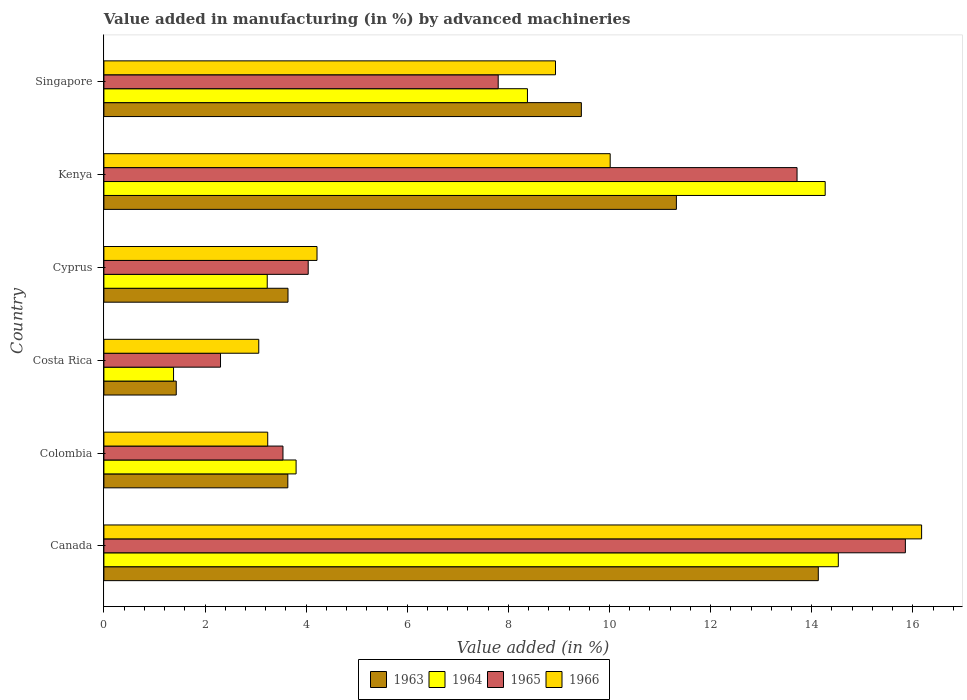How many different coloured bars are there?
Provide a short and direct response. 4. How many groups of bars are there?
Offer a very short reply. 6. What is the label of the 5th group of bars from the top?
Make the answer very short. Colombia. What is the percentage of value added in manufacturing by advanced machineries in 1963 in Kenya?
Offer a terse response. 11.32. Across all countries, what is the maximum percentage of value added in manufacturing by advanced machineries in 1965?
Keep it short and to the point. 15.85. Across all countries, what is the minimum percentage of value added in manufacturing by advanced machineries in 1963?
Keep it short and to the point. 1.43. In which country was the percentage of value added in manufacturing by advanced machineries in 1966 maximum?
Give a very brief answer. Canada. What is the total percentage of value added in manufacturing by advanced machineries in 1966 in the graph?
Your answer should be compact. 45.64. What is the difference between the percentage of value added in manufacturing by advanced machineries in 1963 in Kenya and that in Singapore?
Your answer should be very brief. 1.88. What is the difference between the percentage of value added in manufacturing by advanced machineries in 1966 in Colombia and the percentage of value added in manufacturing by advanced machineries in 1963 in Canada?
Offer a very short reply. -10.89. What is the average percentage of value added in manufacturing by advanced machineries in 1963 per country?
Your answer should be very brief. 7.27. What is the difference between the percentage of value added in manufacturing by advanced machineries in 1965 and percentage of value added in manufacturing by advanced machineries in 1964 in Colombia?
Keep it short and to the point. -0.26. In how many countries, is the percentage of value added in manufacturing by advanced machineries in 1963 greater than 2.4 %?
Provide a succinct answer. 5. What is the ratio of the percentage of value added in manufacturing by advanced machineries in 1965 in Kenya to that in Singapore?
Give a very brief answer. 1.76. Is the percentage of value added in manufacturing by advanced machineries in 1965 in Cyprus less than that in Kenya?
Make the answer very short. Yes. Is the difference between the percentage of value added in manufacturing by advanced machineries in 1965 in Canada and Colombia greater than the difference between the percentage of value added in manufacturing by advanced machineries in 1964 in Canada and Colombia?
Your answer should be very brief. Yes. What is the difference between the highest and the second highest percentage of value added in manufacturing by advanced machineries in 1964?
Ensure brevity in your answer.  0.26. What is the difference between the highest and the lowest percentage of value added in manufacturing by advanced machineries in 1963?
Your answer should be very brief. 12.7. What does the 2nd bar from the top in Costa Rica represents?
Your response must be concise. 1965. What does the 3rd bar from the bottom in Kenya represents?
Keep it short and to the point. 1965. Is it the case that in every country, the sum of the percentage of value added in manufacturing by advanced machineries in 1964 and percentage of value added in manufacturing by advanced machineries in 1966 is greater than the percentage of value added in manufacturing by advanced machineries in 1963?
Your answer should be compact. Yes. Are all the bars in the graph horizontal?
Offer a terse response. Yes. Does the graph contain any zero values?
Your answer should be very brief. No. Does the graph contain grids?
Make the answer very short. No. How many legend labels are there?
Your answer should be very brief. 4. What is the title of the graph?
Provide a short and direct response. Value added in manufacturing (in %) by advanced machineries. Does "1988" appear as one of the legend labels in the graph?
Provide a succinct answer. No. What is the label or title of the X-axis?
Your response must be concise. Value added (in %). What is the label or title of the Y-axis?
Offer a very short reply. Country. What is the Value added (in %) in 1963 in Canada?
Your answer should be compact. 14.13. What is the Value added (in %) in 1964 in Canada?
Offer a very short reply. 14.53. What is the Value added (in %) in 1965 in Canada?
Ensure brevity in your answer.  15.85. What is the Value added (in %) of 1966 in Canada?
Make the answer very short. 16.17. What is the Value added (in %) of 1963 in Colombia?
Provide a short and direct response. 3.64. What is the Value added (in %) in 1964 in Colombia?
Provide a succinct answer. 3.8. What is the Value added (in %) of 1965 in Colombia?
Provide a short and direct response. 3.54. What is the Value added (in %) of 1966 in Colombia?
Provide a short and direct response. 3.24. What is the Value added (in %) in 1963 in Costa Rica?
Keep it short and to the point. 1.43. What is the Value added (in %) in 1964 in Costa Rica?
Your answer should be compact. 1.38. What is the Value added (in %) in 1965 in Costa Rica?
Provide a short and direct response. 2.31. What is the Value added (in %) of 1966 in Costa Rica?
Offer a terse response. 3.06. What is the Value added (in %) of 1963 in Cyprus?
Provide a succinct answer. 3.64. What is the Value added (in %) in 1964 in Cyprus?
Your answer should be very brief. 3.23. What is the Value added (in %) in 1965 in Cyprus?
Make the answer very short. 4.04. What is the Value added (in %) in 1966 in Cyprus?
Make the answer very short. 4.22. What is the Value added (in %) of 1963 in Kenya?
Give a very brief answer. 11.32. What is the Value added (in %) in 1964 in Kenya?
Offer a very short reply. 14.27. What is the Value added (in %) in 1965 in Kenya?
Your answer should be compact. 13.71. What is the Value added (in %) in 1966 in Kenya?
Offer a very short reply. 10.01. What is the Value added (in %) in 1963 in Singapore?
Offer a terse response. 9.44. What is the Value added (in %) in 1964 in Singapore?
Give a very brief answer. 8.38. What is the Value added (in %) of 1965 in Singapore?
Offer a terse response. 7.8. What is the Value added (in %) of 1966 in Singapore?
Offer a very short reply. 8.93. Across all countries, what is the maximum Value added (in %) of 1963?
Your answer should be compact. 14.13. Across all countries, what is the maximum Value added (in %) in 1964?
Give a very brief answer. 14.53. Across all countries, what is the maximum Value added (in %) of 1965?
Provide a short and direct response. 15.85. Across all countries, what is the maximum Value added (in %) in 1966?
Ensure brevity in your answer.  16.17. Across all countries, what is the minimum Value added (in %) in 1963?
Give a very brief answer. 1.43. Across all countries, what is the minimum Value added (in %) in 1964?
Offer a terse response. 1.38. Across all countries, what is the minimum Value added (in %) in 1965?
Your answer should be very brief. 2.31. Across all countries, what is the minimum Value added (in %) of 1966?
Offer a very short reply. 3.06. What is the total Value added (in %) in 1963 in the graph?
Make the answer very short. 43.61. What is the total Value added (in %) in 1964 in the graph?
Make the answer very short. 45.58. What is the total Value added (in %) of 1965 in the graph?
Offer a very short reply. 47.25. What is the total Value added (in %) of 1966 in the graph?
Provide a short and direct response. 45.64. What is the difference between the Value added (in %) of 1963 in Canada and that in Colombia?
Your answer should be very brief. 10.49. What is the difference between the Value added (in %) in 1964 in Canada and that in Colombia?
Provide a short and direct response. 10.72. What is the difference between the Value added (in %) of 1965 in Canada and that in Colombia?
Offer a very short reply. 12.31. What is the difference between the Value added (in %) of 1966 in Canada and that in Colombia?
Provide a short and direct response. 12.93. What is the difference between the Value added (in %) in 1963 in Canada and that in Costa Rica?
Offer a terse response. 12.7. What is the difference between the Value added (in %) in 1964 in Canada and that in Costa Rica?
Your response must be concise. 13.15. What is the difference between the Value added (in %) in 1965 in Canada and that in Costa Rica?
Ensure brevity in your answer.  13.55. What is the difference between the Value added (in %) of 1966 in Canada and that in Costa Rica?
Provide a short and direct response. 13.11. What is the difference between the Value added (in %) in 1963 in Canada and that in Cyprus?
Provide a short and direct response. 10.49. What is the difference between the Value added (in %) in 1964 in Canada and that in Cyprus?
Provide a succinct answer. 11.3. What is the difference between the Value added (in %) in 1965 in Canada and that in Cyprus?
Provide a short and direct response. 11.81. What is the difference between the Value added (in %) of 1966 in Canada and that in Cyprus?
Provide a short and direct response. 11.96. What is the difference between the Value added (in %) in 1963 in Canada and that in Kenya?
Offer a terse response. 2.81. What is the difference between the Value added (in %) of 1964 in Canada and that in Kenya?
Offer a very short reply. 0.26. What is the difference between the Value added (in %) of 1965 in Canada and that in Kenya?
Provide a succinct answer. 2.14. What is the difference between the Value added (in %) in 1966 in Canada and that in Kenya?
Offer a very short reply. 6.16. What is the difference between the Value added (in %) of 1963 in Canada and that in Singapore?
Offer a terse response. 4.69. What is the difference between the Value added (in %) of 1964 in Canada and that in Singapore?
Ensure brevity in your answer.  6.15. What is the difference between the Value added (in %) in 1965 in Canada and that in Singapore?
Ensure brevity in your answer.  8.05. What is the difference between the Value added (in %) in 1966 in Canada and that in Singapore?
Offer a terse response. 7.24. What is the difference between the Value added (in %) in 1963 in Colombia and that in Costa Rica?
Make the answer very short. 2.21. What is the difference between the Value added (in %) of 1964 in Colombia and that in Costa Rica?
Provide a succinct answer. 2.42. What is the difference between the Value added (in %) in 1965 in Colombia and that in Costa Rica?
Provide a succinct answer. 1.24. What is the difference between the Value added (in %) of 1966 in Colombia and that in Costa Rica?
Keep it short and to the point. 0.18. What is the difference between the Value added (in %) in 1963 in Colombia and that in Cyprus?
Ensure brevity in your answer.  -0. What is the difference between the Value added (in %) in 1964 in Colombia and that in Cyprus?
Ensure brevity in your answer.  0.57. What is the difference between the Value added (in %) in 1965 in Colombia and that in Cyprus?
Keep it short and to the point. -0.5. What is the difference between the Value added (in %) of 1966 in Colombia and that in Cyprus?
Provide a short and direct response. -0.97. What is the difference between the Value added (in %) of 1963 in Colombia and that in Kenya?
Provide a succinct answer. -7.69. What is the difference between the Value added (in %) in 1964 in Colombia and that in Kenya?
Provide a short and direct response. -10.47. What is the difference between the Value added (in %) of 1965 in Colombia and that in Kenya?
Offer a very short reply. -10.17. What is the difference between the Value added (in %) in 1966 in Colombia and that in Kenya?
Ensure brevity in your answer.  -6.77. What is the difference between the Value added (in %) of 1963 in Colombia and that in Singapore?
Provide a succinct answer. -5.81. What is the difference between the Value added (in %) of 1964 in Colombia and that in Singapore?
Offer a terse response. -4.58. What is the difference between the Value added (in %) in 1965 in Colombia and that in Singapore?
Your response must be concise. -4.26. What is the difference between the Value added (in %) of 1966 in Colombia and that in Singapore?
Offer a very short reply. -5.69. What is the difference between the Value added (in %) in 1963 in Costa Rica and that in Cyprus?
Make the answer very short. -2.21. What is the difference between the Value added (in %) of 1964 in Costa Rica and that in Cyprus?
Provide a succinct answer. -1.85. What is the difference between the Value added (in %) of 1965 in Costa Rica and that in Cyprus?
Provide a short and direct response. -1.73. What is the difference between the Value added (in %) in 1966 in Costa Rica and that in Cyprus?
Your answer should be very brief. -1.15. What is the difference between the Value added (in %) of 1963 in Costa Rica and that in Kenya?
Offer a very short reply. -9.89. What is the difference between the Value added (in %) in 1964 in Costa Rica and that in Kenya?
Ensure brevity in your answer.  -12.89. What is the difference between the Value added (in %) in 1965 in Costa Rica and that in Kenya?
Your answer should be very brief. -11.4. What is the difference between the Value added (in %) in 1966 in Costa Rica and that in Kenya?
Make the answer very short. -6.95. What is the difference between the Value added (in %) of 1963 in Costa Rica and that in Singapore?
Your response must be concise. -8.01. What is the difference between the Value added (in %) of 1964 in Costa Rica and that in Singapore?
Give a very brief answer. -7. What is the difference between the Value added (in %) in 1965 in Costa Rica and that in Singapore?
Ensure brevity in your answer.  -5.49. What is the difference between the Value added (in %) of 1966 in Costa Rica and that in Singapore?
Make the answer very short. -5.87. What is the difference between the Value added (in %) of 1963 in Cyprus and that in Kenya?
Your response must be concise. -7.68. What is the difference between the Value added (in %) in 1964 in Cyprus and that in Kenya?
Make the answer very short. -11.04. What is the difference between the Value added (in %) of 1965 in Cyprus and that in Kenya?
Your response must be concise. -9.67. What is the difference between the Value added (in %) in 1966 in Cyprus and that in Kenya?
Make the answer very short. -5.8. What is the difference between the Value added (in %) in 1963 in Cyprus and that in Singapore?
Offer a terse response. -5.8. What is the difference between the Value added (in %) of 1964 in Cyprus and that in Singapore?
Make the answer very short. -5.15. What is the difference between the Value added (in %) of 1965 in Cyprus and that in Singapore?
Offer a terse response. -3.76. What is the difference between the Value added (in %) in 1966 in Cyprus and that in Singapore?
Ensure brevity in your answer.  -4.72. What is the difference between the Value added (in %) of 1963 in Kenya and that in Singapore?
Your response must be concise. 1.88. What is the difference between the Value added (in %) in 1964 in Kenya and that in Singapore?
Your answer should be very brief. 5.89. What is the difference between the Value added (in %) in 1965 in Kenya and that in Singapore?
Offer a very short reply. 5.91. What is the difference between the Value added (in %) in 1966 in Kenya and that in Singapore?
Your answer should be compact. 1.08. What is the difference between the Value added (in %) in 1963 in Canada and the Value added (in %) in 1964 in Colombia?
Make the answer very short. 10.33. What is the difference between the Value added (in %) in 1963 in Canada and the Value added (in %) in 1965 in Colombia?
Give a very brief answer. 10.59. What is the difference between the Value added (in %) in 1963 in Canada and the Value added (in %) in 1966 in Colombia?
Your response must be concise. 10.89. What is the difference between the Value added (in %) in 1964 in Canada and the Value added (in %) in 1965 in Colombia?
Ensure brevity in your answer.  10.98. What is the difference between the Value added (in %) in 1964 in Canada and the Value added (in %) in 1966 in Colombia?
Offer a terse response. 11.29. What is the difference between the Value added (in %) in 1965 in Canada and the Value added (in %) in 1966 in Colombia?
Give a very brief answer. 12.61. What is the difference between the Value added (in %) in 1963 in Canada and the Value added (in %) in 1964 in Costa Rica?
Your answer should be compact. 12.75. What is the difference between the Value added (in %) in 1963 in Canada and the Value added (in %) in 1965 in Costa Rica?
Keep it short and to the point. 11.82. What is the difference between the Value added (in %) in 1963 in Canada and the Value added (in %) in 1966 in Costa Rica?
Keep it short and to the point. 11.07. What is the difference between the Value added (in %) in 1964 in Canada and the Value added (in %) in 1965 in Costa Rica?
Your answer should be very brief. 12.22. What is the difference between the Value added (in %) in 1964 in Canada and the Value added (in %) in 1966 in Costa Rica?
Make the answer very short. 11.46. What is the difference between the Value added (in %) of 1965 in Canada and the Value added (in %) of 1966 in Costa Rica?
Offer a terse response. 12.79. What is the difference between the Value added (in %) in 1963 in Canada and the Value added (in %) in 1964 in Cyprus?
Give a very brief answer. 10.9. What is the difference between the Value added (in %) of 1963 in Canada and the Value added (in %) of 1965 in Cyprus?
Offer a very short reply. 10.09. What is the difference between the Value added (in %) of 1963 in Canada and the Value added (in %) of 1966 in Cyprus?
Your response must be concise. 9.92. What is the difference between the Value added (in %) in 1964 in Canada and the Value added (in %) in 1965 in Cyprus?
Make the answer very short. 10.49. What is the difference between the Value added (in %) of 1964 in Canada and the Value added (in %) of 1966 in Cyprus?
Offer a very short reply. 10.31. What is the difference between the Value added (in %) in 1965 in Canada and the Value added (in %) in 1966 in Cyprus?
Give a very brief answer. 11.64. What is the difference between the Value added (in %) in 1963 in Canada and the Value added (in %) in 1964 in Kenya?
Your answer should be very brief. -0.14. What is the difference between the Value added (in %) of 1963 in Canada and the Value added (in %) of 1965 in Kenya?
Offer a very short reply. 0.42. What is the difference between the Value added (in %) in 1963 in Canada and the Value added (in %) in 1966 in Kenya?
Keep it short and to the point. 4.12. What is the difference between the Value added (in %) of 1964 in Canada and the Value added (in %) of 1965 in Kenya?
Your response must be concise. 0.82. What is the difference between the Value added (in %) of 1964 in Canada and the Value added (in %) of 1966 in Kenya?
Your response must be concise. 4.51. What is the difference between the Value added (in %) of 1965 in Canada and the Value added (in %) of 1966 in Kenya?
Offer a terse response. 5.84. What is the difference between the Value added (in %) in 1963 in Canada and the Value added (in %) in 1964 in Singapore?
Make the answer very short. 5.75. What is the difference between the Value added (in %) in 1963 in Canada and the Value added (in %) in 1965 in Singapore?
Make the answer very short. 6.33. What is the difference between the Value added (in %) in 1963 in Canada and the Value added (in %) in 1966 in Singapore?
Offer a terse response. 5.2. What is the difference between the Value added (in %) of 1964 in Canada and the Value added (in %) of 1965 in Singapore?
Your answer should be compact. 6.73. What is the difference between the Value added (in %) in 1964 in Canada and the Value added (in %) in 1966 in Singapore?
Offer a very short reply. 5.59. What is the difference between the Value added (in %) in 1965 in Canada and the Value added (in %) in 1966 in Singapore?
Make the answer very short. 6.92. What is the difference between the Value added (in %) in 1963 in Colombia and the Value added (in %) in 1964 in Costa Rica?
Provide a succinct answer. 2.26. What is the difference between the Value added (in %) of 1963 in Colombia and the Value added (in %) of 1965 in Costa Rica?
Keep it short and to the point. 1.33. What is the difference between the Value added (in %) in 1963 in Colombia and the Value added (in %) in 1966 in Costa Rica?
Provide a succinct answer. 0.57. What is the difference between the Value added (in %) in 1964 in Colombia and the Value added (in %) in 1965 in Costa Rica?
Offer a terse response. 1.49. What is the difference between the Value added (in %) of 1964 in Colombia and the Value added (in %) of 1966 in Costa Rica?
Offer a very short reply. 0.74. What is the difference between the Value added (in %) of 1965 in Colombia and the Value added (in %) of 1966 in Costa Rica?
Ensure brevity in your answer.  0.48. What is the difference between the Value added (in %) of 1963 in Colombia and the Value added (in %) of 1964 in Cyprus?
Give a very brief answer. 0.41. What is the difference between the Value added (in %) in 1963 in Colombia and the Value added (in %) in 1965 in Cyprus?
Provide a short and direct response. -0.4. What is the difference between the Value added (in %) in 1963 in Colombia and the Value added (in %) in 1966 in Cyprus?
Offer a very short reply. -0.58. What is the difference between the Value added (in %) of 1964 in Colombia and the Value added (in %) of 1965 in Cyprus?
Provide a short and direct response. -0.24. What is the difference between the Value added (in %) of 1964 in Colombia and the Value added (in %) of 1966 in Cyprus?
Provide a short and direct response. -0.41. What is the difference between the Value added (in %) in 1965 in Colombia and the Value added (in %) in 1966 in Cyprus?
Your response must be concise. -0.67. What is the difference between the Value added (in %) in 1963 in Colombia and the Value added (in %) in 1964 in Kenya?
Provide a succinct answer. -10.63. What is the difference between the Value added (in %) in 1963 in Colombia and the Value added (in %) in 1965 in Kenya?
Offer a terse response. -10.07. What is the difference between the Value added (in %) in 1963 in Colombia and the Value added (in %) in 1966 in Kenya?
Offer a very short reply. -6.38. What is the difference between the Value added (in %) in 1964 in Colombia and the Value added (in %) in 1965 in Kenya?
Your response must be concise. -9.91. What is the difference between the Value added (in %) in 1964 in Colombia and the Value added (in %) in 1966 in Kenya?
Offer a very short reply. -6.21. What is the difference between the Value added (in %) of 1965 in Colombia and the Value added (in %) of 1966 in Kenya?
Your answer should be very brief. -6.47. What is the difference between the Value added (in %) of 1963 in Colombia and the Value added (in %) of 1964 in Singapore?
Provide a short and direct response. -4.74. What is the difference between the Value added (in %) in 1963 in Colombia and the Value added (in %) in 1965 in Singapore?
Your answer should be very brief. -4.16. What is the difference between the Value added (in %) of 1963 in Colombia and the Value added (in %) of 1966 in Singapore?
Offer a very short reply. -5.29. What is the difference between the Value added (in %) in 1964 in Colombia and the Value added (in %) in 1965 in Singapore?
Your answer should be very brief. -4. What is the difference between the Value added (in %) in 1964 in Colombia and the Value added (in %) in 1966 in Singapore?
Your answer should be very brief. -5.13. What is the difference between the Value added (in %) in 1965 in Colombia and the Value added (in %) in 1966 in Singapore?
Your answer should be compact. -5.39. What is the difference between the Value added (in %) of 1963 in Costa Rica and the Value added (in %) of 1964 in Cyprus?
Provide a short and direct response. -1.8. What is the difference between the Value added (in %) of 1963 in Costa Rica and the Value added (in %) of 1965 in Cyprus?
Your answer should be very brief. -2.61. What is the difference between the Value added (in %) of 1963 in Costa Rica and the Value added (in %) of 1966 in Cyprus?
Keep it short and to the point. -2.78. What is the difference between the Value added (in %) of 1964 in Costa Rica and the Value added (in %) of 1965 in Cyprus?
Provide a short and direct response. -2.66. What is the difference between the Value added (in %) in 1964 in Costa Rica and the Value added (in %) in 1966 in Cyprus?
Your answer should be compact. -2.84. What is the difference between the Value added (in %) in 1965 in Costa Rica and the Value added (in %) in 1966 in Cyprus?
Make the answer very short. -1.91. What is the difference between the Value added (in %) of 1963 in Costa Rica and the Value added (in %) of 1964 in Kenya?
Ensure brevity in your answer.  -12.84. What is the difference between the Value added (in %) in 1963 in Costa Rica and the Value added (in %) in 1965 in Kenya?
Keep it short and to the point. -12.28. What is the difference between the Value added (in %) of 1963 in Costa Rica and the Value added (in %) of 1966 in Kenya?
Provide a short and direct response. -8.58. What is the difference between the Value added (in %) of 1964 in Costa Rica and the Value added (in %) of 1965 in Kenya?
Keep it short and to the point. -12.33. What is the difference between the Value added (in %) of 1964 in Costa Rica and the Value added (in %) of 1966 in Kenya?
Keep it short and to the point. -8.64. What is the difference between the Value added (in %) of 1965 in Costa Rica and the Value added (in %) of 1966 in Kenya?
Ensure brevity in your answer.  -7.71. What is the difference between the Value added (in %) of 1963 in Costa Rica and the Value added (in %) of 1964 in Singapore?
Provide a succinct answer. -6.95. What is the difference between the Value added (in %) of 1963 in Costa Rica and the Value added (in %) of 1965 in Singapore?
Keep it short and to the point. -6.37. What is the difference between the Value added (in %) in 1963 in Costa Rica and the Value added (in %) in 1966 in Singapore?
Provide a succinct answer. -7.5. What is the difference between the Value added (in %) in 1964 in Costa Rica and the Value added (in %) in 1965 in Singapore?
Offer a very short reply. -6.42. What is the difference between the Value added (in %) of 1964 in Costa Rica and the Value added (in %) of 1966 in Singapore?
Ensure brevity in your answer.  -7.55. What is the difference between the Value added (in %) in 1965 in Costa Rica and the Value added (in %) in 1966 in Singapore?
Give a very brief answer. -6.63. What is the difference between the Value added (in %) of 1963 in Cyprus and the Value added (in %) of 1964 in Kenya?
Your response must be concise. -10.63. What is the difference between the Value added (in %) in 1963 in Cyprus and the Value added (in %) in 1965 in Kenya?
Your answer should be compact. -10.07. What is the difference between the Value added (in %) of 1963 in Cyprus and the Value added (in %) of 1966 in Kenya?
Your answer should be compact. -6.37. What is the difference between the Value added (in %) in 1964 in Cyprus and the Value added (in %) in 1965 in Kenya?
Your response must be concise. -10.48. What is the difference between the Value added (in %) of 1964 in Cyprus and the Value added (in %) of 1966 in Kenya?
Provide a succinct answer. -6.78. What is the difference between the Value added (in %) in 1965 in Cyprus and the Value added (in %) in 1966 in Kenya?
Make the answer very short. -5.97. What is the difference between the Value added (in %) of 1963 in Cyprus and the Value added (in %) of 1964 in Singapore?
Offer a terse response. -4.74. What is the difference between the Value added (in %) in 1963 in Cyprus and the Value added (in %) in 1965 in Singapore?
Keep it short and to the point. -4.16. What is the difference between the Value added (in %) in 1963 in Cyprus and the Value added (in %) in 1966 in Singapore?
Keep it short and to the point. -5.29. What is the difference between the Value added (in %) in 1964 in Cyprus and the Value added (in %) in 1965 in Singapore?
Provide a succinct answer. -4.57. What is the difference between the Value added (in %) in 1964 in Cyprus and the Value added (in %) in 1966 in Singapore?
Offer a very short reply. -5.7. What is the difference between the Value added (in %) of 1965 in Cyprus and the Value added (in %) of 1966 in Singapore?
Your response must be concise. -4.89. What is the difference between the Value added (in %) in 1963 in Kenya and the Value added (in %) in 1964 in Singapore?
Your answer should be compact. 2.95. What is the difference between the Value added (in %) in 1963 in Kenya and the Value added (in %) in 1965 in Singapore?
Your answer should be very brief. 3.52. What is the difference between the Value added (in %) in 1963 in Kenya and the Value added (in %) in 1966 in Singapore?
Offer a terse response. 2.39. What is the difference between the Value added (in %) of 1964 in Kenya and the Value added (in %) of 1965 in Singapore?
Offer a terse response. 6.47. What is the difference between the Value added (in %) in 1964 in Kenya and the Value added (in %) in 1966 in Singapore?
Your answer should be compact. 5.33. What is the difference between the Value added (in %) in 1965 in Kenya and the Value added (in %) in 1966 in Singapore?
Offer a terse response. 4.78. What is the average Value added (in %) of 1963 per country?
Provide a short and direct response. 7.27. What is the average Value added (in %) in 1964 per country?
Keep it short and to the point. 7.6. What is the average Value added (in %) in 1965 per country?
Your response must be concise. 7.88. What is the average Value added (in %) in 1966 per country?
Keep it short and to the point. 7.61. What is the difference between the Value added (in %) in 1963 and Value added (in %) in 1964 in Canada?
Offer a terse response. -0.4. What is the difference between the Value added (in %) of 1963 and Value added (in %) of 1965 in Canada?
Make the answer very short. -1.72. What is the difference between the Value added (in %) in 1963 and Value added (in %) in 1966 in Canada?
Your answer should be very brief. -2.04. What is the difference between the Value added (in %) in 1964 and Value added (in %) in 1965 in Canada?
Keep it short and to the point. -1.33. What is the difference between the Value added (in %) of 1964 and Value added (in %) of 1966 in Canada?
Offer a very short reply. -1.65. What is the difference between the Value added (in %) in 1965 and Value added (in %) in 1966 in Canada?
Ensure brevity in your answer.  -0.32. What is the difference between the Value added (in %) in 1963 and Value added (in %) in 1964 in Colombia?
Give a very brief answer. -0.16. What is the difference between the Value added (in %) of 1963 and Value added (in %) of 1965 in Colombia?
Keep it short and to the point. 0.1. What is the difference between the Value added (in %) of 1963 and Value added (in %) of 1966 in Colombia?
Your answer should be compact. 0.4. What is the difference between the Value added (in %) of 1964 and Value added (in %) of 1965 in Colombia?
Your answer should be very brief. 0.26. What is the difference between the Value added (in %) of 1964 and Value added (in %) of 1966 in Colombia?
Offer a very short reply. 0.56. What is the difference between the Value added (in %) of 1965 and Value added (in %) of 1966 in Colombia?
Offer a very short reply. 0.3. What is the difference between the Value added (in %) of 1963 and Value added (in %) of 1964 in Costa Rica?
Your response must be concise. 0.05. What is the difference between the Value added (in %) of 1963 and Value added (in %) of 1965 in Costa Rica?
Your response must be concise. -0.88. What is the difference between the Value added (in %) of 1963 and Value added (in %) of 1966 in Costa Rica?
Your answer should be compact. -1.63. What is the difference between the Value added (in %) of 1964 and Value added (in %) of 1965 in Costa Rica?
Offer a terse response. -0.93. What is the difference between the Value added (in %) of 1964 and Value added (in %) of 1966 in Costa Rica?
Offer a very short reply. -1.69. What is the difference between the Value added (in %) in 1965 and Value added (in %) in 1966 in Costa Rica?
Offer a terse response. -0.76. What is the difference between the Value added (in %) in 1963 and Value added (in %) in 1964 in Cyprus?
Make the answer very short. 0.41. What is the difference between the Value added (in %) in 1963 and Value added (in %) in 1965 in Cyprus?
Your response must be concise. -0.4. What is the difference between the Value added (in %) of 1963 and Value added (in %) of 1966 in Cyprus?
Your answer should be compact. -0.57. What is the difference between the Value added (in %) of 1964 and Value added (in %) of 1965 in Cyprus?
Your response must be concise. -0.81. What is the difference between the Value added (in %) of 1964 and Value added (in %) of 1966 in Cyprus?
Your answer should be very brief. -0.98. What is the difference between the Value added (in %) in 1965 and Value added (in %) in 1966 in Cyprus?
Your answer should be compact. -0.17. What is the difference between the Value added (in %) of 1963 and Value added (in %) of 1964 in Kenya?
Your response must be concise. -2.94. What is the difference between the Value added (in %) of 1963 and Value added (in %) of 1965 in Kenya?
Offer a very short reply. -2.39. What is the difference between the Value added (in %) in 1963 and Value added (in %) in 1966 in Kenya?
Give a very brief answer. 1.31. What is the difference between the Value added (in %) in 1964 and Value added (in %) in 1965 in Kenya?
Your answer should be very brief. 0.56. What is the difference between the Value added (in %) in 1964 and Value added (in %) in 1966 in Kenya?
Offer a terse response. 4.25. What is the difference between the Value added (in %) of 1965 and Value added (in %) of 1966 in Kenya?
Your response must be concise. 3.7. What is the difference between the Value added (in %) of 1963 and Value added (in %) of 1964 in Singapore?
Provide a short and direct response. 1.07. What is the difference between the Value added (in %) of 1963 and Value added (in %) of 1965 in Singapore?
Your response must be concise. 1.64. What is the difference between the Value added (in %) in 1963 and Value added (in %) in 1966 in Singapore?
Make the answer very short. 0.51. What is the difference between the Value added (in %) of 1964 and Value added (in %) of 1965 in Singapore?
Offer a terse response. 0.58. What is the difference between the Value added (in %) in 1964 and Value added (in %) in 1966 in Singapore?
Your answer should be very brief. -0.55. What is the difference between the Value added (in %) of 1965 and Value added (in %) of 1966 in Singapore?
Ensure brevity in your answer.  -1.13. What is the ratio of the Value added (in %) in 1963 in Canada to that in Colombia?
Offer a very short reply. 3.88. What is the ratio of the Value added (in %) in 1964 in Canada to that in Colombia?
Make the answer very short. 3.82. What is the ratio of the Value added (in %) of 1965 in Canada to that in Colombia?
Your answer should be very brief. 4.48. What is the ratio of the Value added (in %) in 1966 in Canada to that in Colombia?
Your answer should be very brief. 4.99. What is the ratio of the Value added (in %) of 1963 in Canada to that in Costa Rica?
Ensure brevity in your answer.  9.87. What is the ratio of the Value added (in %) in 1964 in Canada to that in Costa Rica?
Provide a short and direct response. 10.54. What is the ratio of the Value added (in %) of 1965 in Canada to that in Costa Rica?
Provide a succinct answer. 6.87. What is the ratio of the Value added (in %) in 1966 in Canada to that in Costa Rica?
Offer a terse response. 5.28. What is the ratio of the Value added (in %) of 1963 in Canada to that in Cyprus?
Offer a terse response. 3.88. What is the ratio of the Value added (in %) of 1964 in Canada to that in Cyprus?
Provide a succinct answer. 4.5. What is the ratio of the Value added (in %) in 1965 in Canada to that in Cyprus?
Give a very brief answer. 3.92. What is the ratio of the Value added (in %) in 1966 in Canada to that in Cyprus?
Offer a very short reply. 3.84. What is the ratio of the Value added (in %) of 1963 in Canada to that in Kenya?
Provide a short and direct response. 1.25. What is the ratio of the Value added (in %) of 1964 in Canada to that in Kenya?
Provide a succinct answer. 1.02. What is the ratio of the Value added (in %) of 1965 in Canada to that in Kenya?
Give a very brief answer. 1.16. What is the ratio of the Value added (in %) in 1966 in Canada to that in Kenya?
Make the answer very short. 1.62. What is the ratio of the Value added (in %) of 1963 in Canada to that in Singapore?
Offer a terse response. 1.5. What is the ratio of the Value added (in %) of 1964 in Canada to that in Singapore?
Ensure brevity in your answer.  1.73. What is the ratio of the Value added (in %) of 1965 in Canada to that in Singapore?
Provide a succinct answer. 2.03. What is the ratio of the Value added (in %) in 1966 in Canada to that in Singapore?
Offer a very short reply. 1.81. What is the ratio of the Value added (in %) in 1963 in Colombia to that in Costa Rica?
Provide a short and direct response. 2.54. What is the ratio of the Value added (in %) of 1964 in Colombia to that in Costa Rica?
Provide a short and direct response. 2.76. What is the ratio of the Value added (in %) of 1965 in Colombia to that in Costa Rica?
Your response must be concise. 1.54. What is the ratio of the Value added (in %) in 1966 in Colombia to that in Costa Rica?
Provide a short and direct response. 1.06. What is the ratio of the Value added (in %) of 1963 in Colombia to that in Cyprus?
Your response must be concise. 1. What is the ratio of the Value added (in %) in 1964 in Colombia to that in Cyprus?
Give a very brief answer. 1.18. What is the ratio of the Value added (in %) of 1965 in Colombia to that in Cyprus?
Keep it short and to the point. 0.88. What is the ratio of the Value added (in %) of 1966 in Colombia to that in Cyprus?
Your answer should be very brief. 0.77. What is the ratio of the Value added (in %) of 1963 in Colombia to that in Kenya?
Your response must be concise. 0.32. What is the ratio of the Value added (in %) in 1964 in Colombia to that in Kenya?
Give a very brief answer. 0.27. What is the ratio of the Value added (in %) in 1965 in Colombia to that in Kenya?
Provide a short and direct response. 0.26. What is the ratio of the Value added (in %) of 1966 in Colombia to that in Kenya?
Give a very brief answer. 0.32. What is the ratio of the Value added (in %) of 1963 in Colombia to that in Singapore?
Offer a very short reply. 0.39. What is the ratio of the Value added (in %) of 1964 in Colombia to that in Singapore?
Offer a very short reply. 0.45. What is the ratio of the Value added (in %) of 1965 in Colombia to that in Singapore?
Give a very brief answer. 0.45. What is the ratio of the Value added (in %) in 1966 in Colombia to that in Singapore?
Offer a very short reply. 0.36. What is the ratio of the Value added (in %) in 1963 in Costa Rica to that in Cyprus?
Make the answer very short. 0.39. What is the ratio of the Value added (in %) in 1964 in Costa Rica to that in Cyprus?
Give a very brief answer. 0.43. What is the ratio of the Value added (in %) in 1965 in Costa Rica to that in Cyprus?
Make the answer very short. 0.57. What is the ratio of the Value added (in %) of 1966 in Costa Rica to that in Cyprus?
Your response must be concise. 0.73. What is the ratio of the Value added (in %) in 1963 in Costa Rica to that in Kenya?
Your response must be concise. 0.13. What is the ratio of the Value added (in %) in 1964 in Costa Rica to that in Kenya?
Keep it short and to the point. 0.1. What is the ratio of the Value added (in %) in 1965 in Costa Rica to that in Kenya?
Your answer should be very brief. 0.17. What is the ratio of the Value added (in %) in 1966 in Costa Rica to that in Kenya?
Make the answer very short. 0.31. What is the ratio of the Value added (in %) of 1963 in Costa Rica to that in Singapore?
Provide a short and direct response. 0.15. What is the ratio of the Value added (in %) in 1964 in Costa Rica to that in Singapore?
Give a very brief answer. 0.16. What is the ratio of the Value added (in %) in 1965 in Costa Rica to that in Singapore?
Offer a very short reply. 0.3. What is the ratio of the Value added (in %) of 1966 in Costa Rica to that in Singapore?
Make the answer very short. 0.34. What is the ratio of the Value added (in %) in 1963 in Cyprus to that in Kenya?
Your answer should be compact. 0.32. What is the ratio of the Value added (in %) of 1964 in Cyprus to that in Kenya?
Offer a terse response. 0.23. What is the ratio of the Value added (in %) of 1965 in Cyprus to that in Kenya?
Your answer should be very brief. 0.29. What is the ratio of the Value added (in %) of 1966 in Cyprus to that in Kenya?
Ensure brevity in your answer.  0.42. What is the ratio of the Value added (in %) in 1963 in Cyprus to that in Singapore?
Your answer should be compact. 0.39. What is the ratio of the Value added (in %) in 1964 in Cyprus to that in Singapore?
Offer a very short reply. 0.39. What is the ratio of the Value added (in %) of 1965 in Cyprus to that in Singapore?
Offer a terse response. 0.52. What is the ratio of the Value added (in %) of 1966 in Cyprus to that in Singapore?
Ensure brevity in your answer.  0.47. What is the ratio of the Value added (in %) of 1963 in Kenya to that in Singapore?
Your response must be concise. 1.2. What is the ratio of the Value added (in %) of 1964 in Kenya to that in Singapore?
Give a very brief answer. 1.7. What is the ratio of the Value added (in %) of 1965 in Kenya to that in Singapore?
Make the answer very short. 1.76. What is the ratio of the Value added (in %) of 1966 in Kenya to that in Singapore?
Your answer should be very brief. 1.12. What is the difference between the highest and the second highest Value added (in %) of 1963?
Offer a very short reply. 2.81. What is the difference between the highest and the second highest Value added (in %) in 1964?
Keep it short and to the point. 0.26. What is the difference between the highest and the second highest Value added (in %) in 1965?
Your answer should be compact. 2.14. What is the difference between the highest and the second highest Value added (in %) in 1966?
Give a very brief answer. 6.16. What is the difference between the highest and the lowest Value added (in %) in 1963?
Keep it short and to the point. 12.7. What is the difference between the highest and the lowest Value added (in %) in 1964?
Ensure brevity in your answer.  13.15. What is the difference between the highest and the lowest Value added (in %) of 1965?
Keep it short and to the point. 13.55. What is the difference between the highest and the lowest Value added (in %) of 1966?
Give a very brief answer. 13.11. 